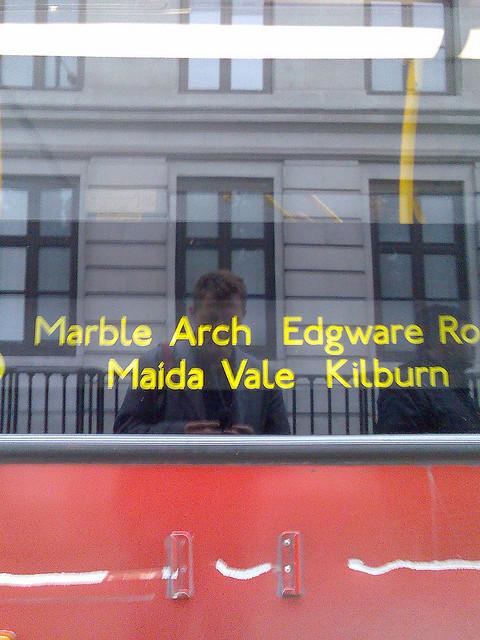Is this a store window?
Be succinct. Yes. How can you tell this is a reflection?
Give a very brief answer. Letters. Where is a black fence?
Write a very short answer. In front of building. 